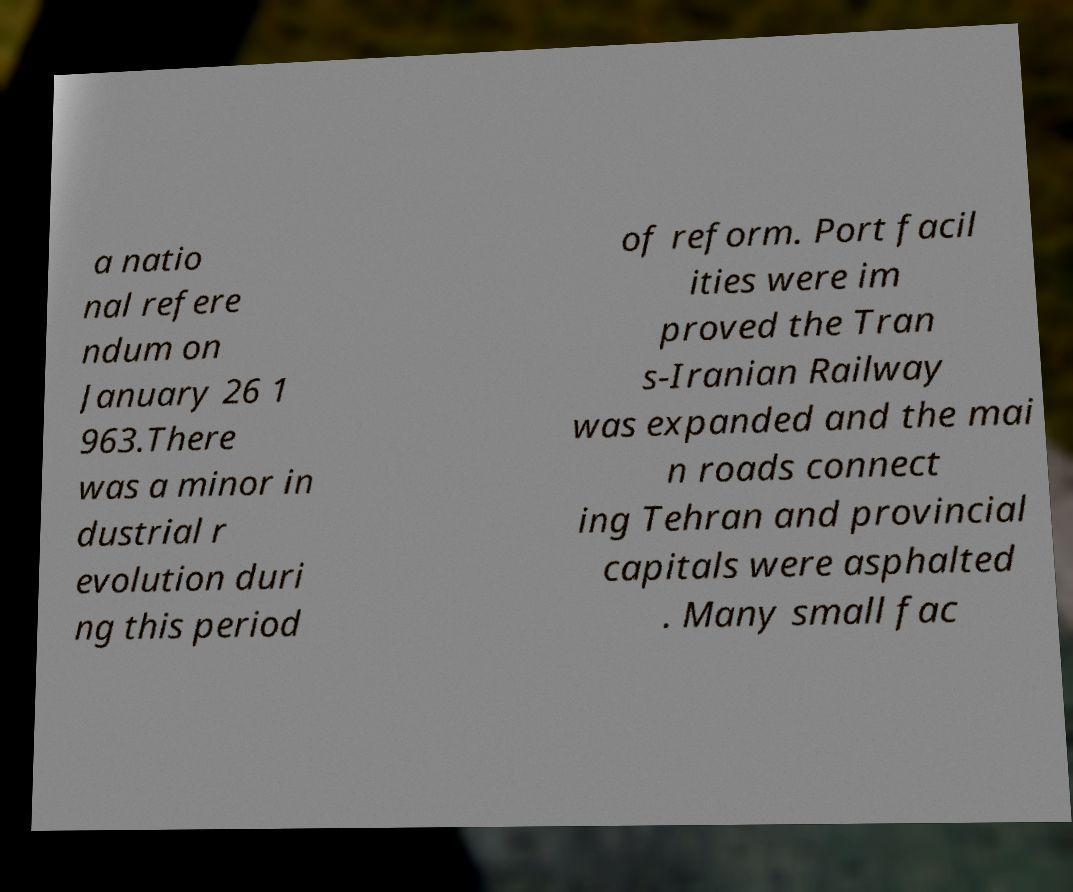Please read and relay the text visible in this image. What does it say? a natio nal refere ndum on January 26 1 963.There was a minor in dustrial r evolution duri ng this period of reform. Port facil ities were im proved the Tran s-Iranian Railway was expanded and the mai n roads connect ing Tehran and provincial capitals were asphalted . Many small fac 